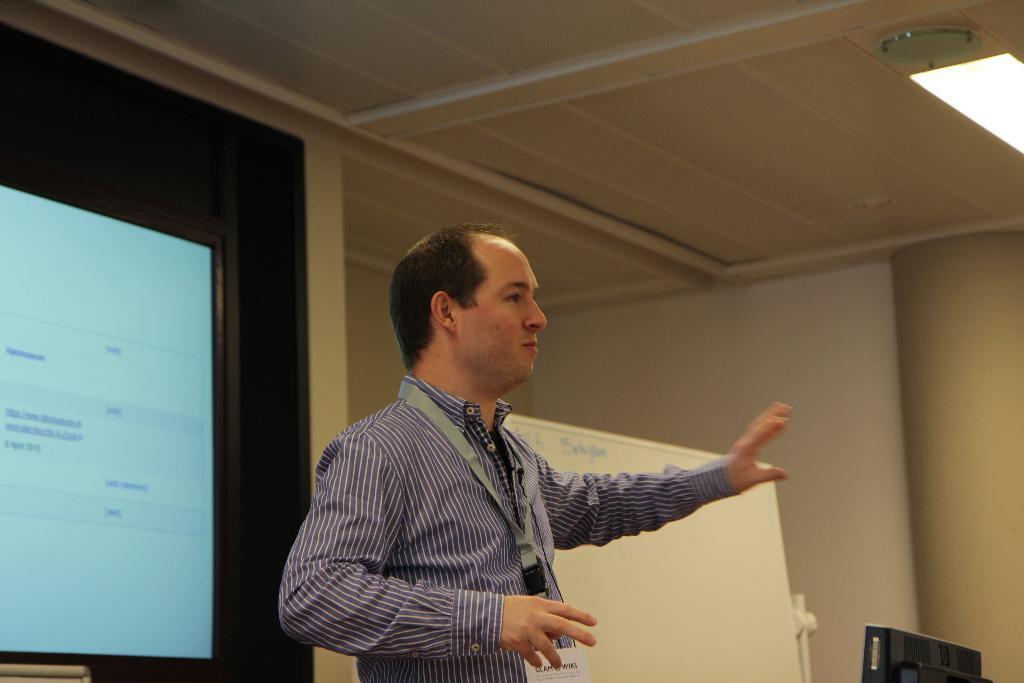Could you give a brief overview of what you see in this image? In this image I can see a person standing wearing purple color shirt. Background I can see a white color board and a projector screen. 